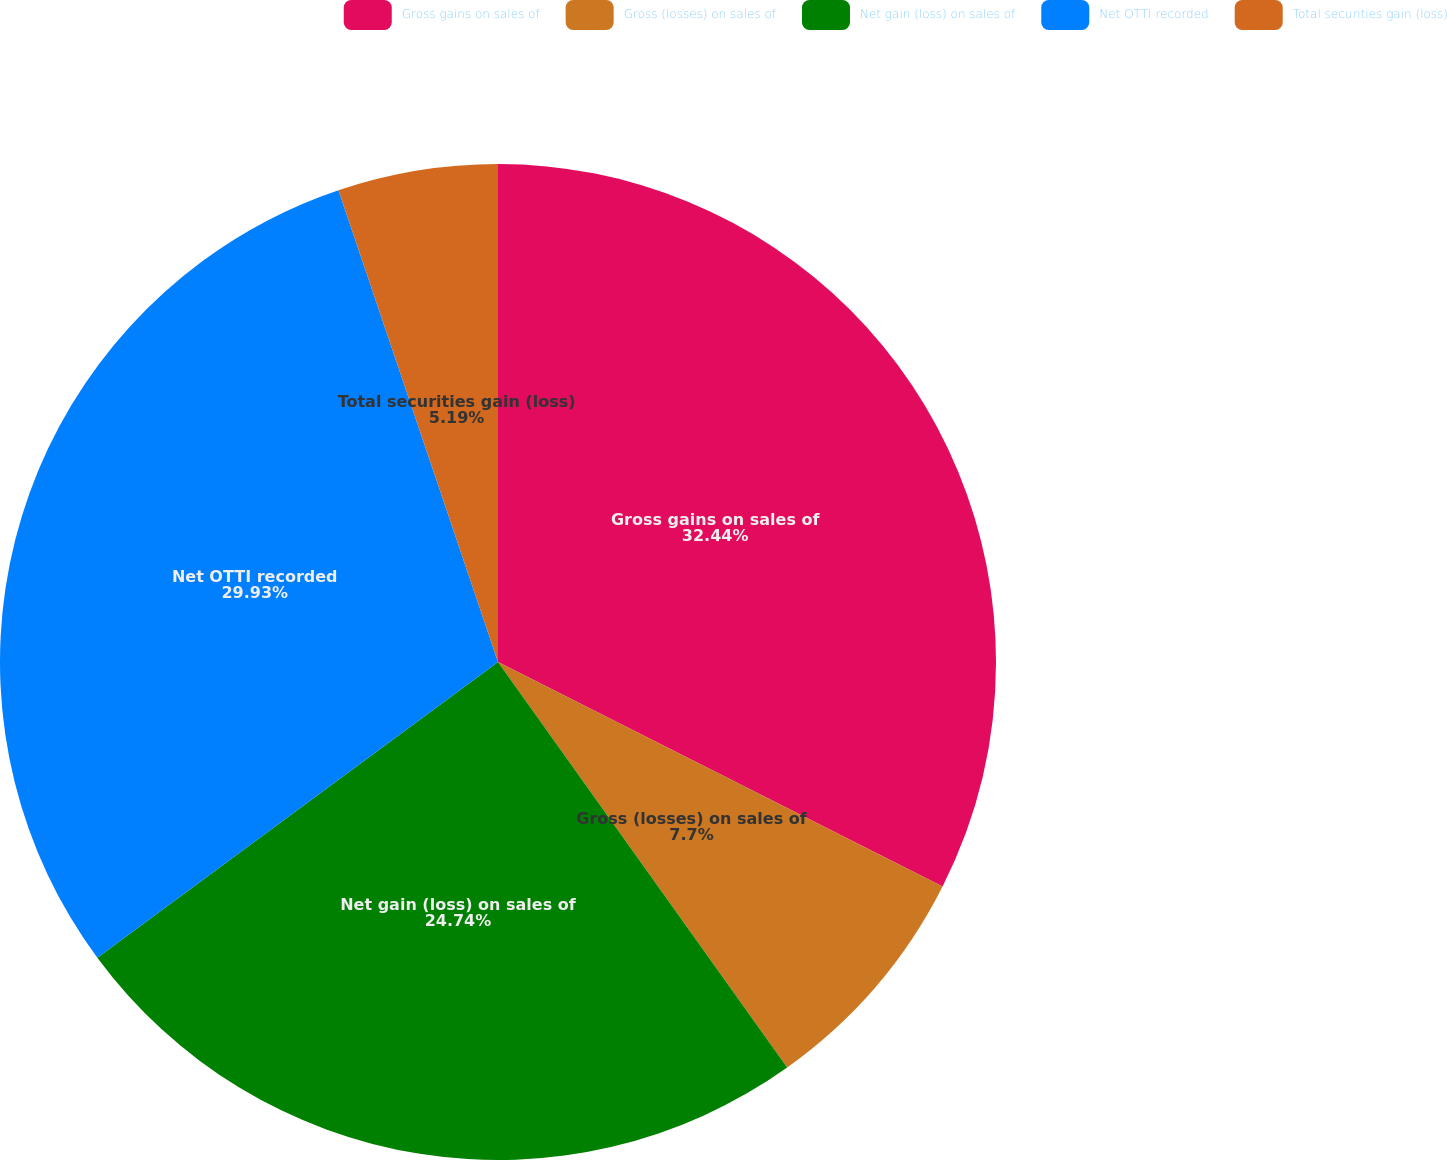Convert chart to OTSL. <chart><loc_0><loc_0><loc_500><loc_500><pie_chart><fcel>Gross gains on sales of<fcel>Gross (losses) on sales of<fcel>Net gain (loss) on sales of<fcel>Net OTTI recorded<fcel>Total securities gain (loss)<nl><fcel>32.44%<fcel>7.7%<fcel>24.74%<fcel>29.93%<fcel>5.19%<nl></chart> 